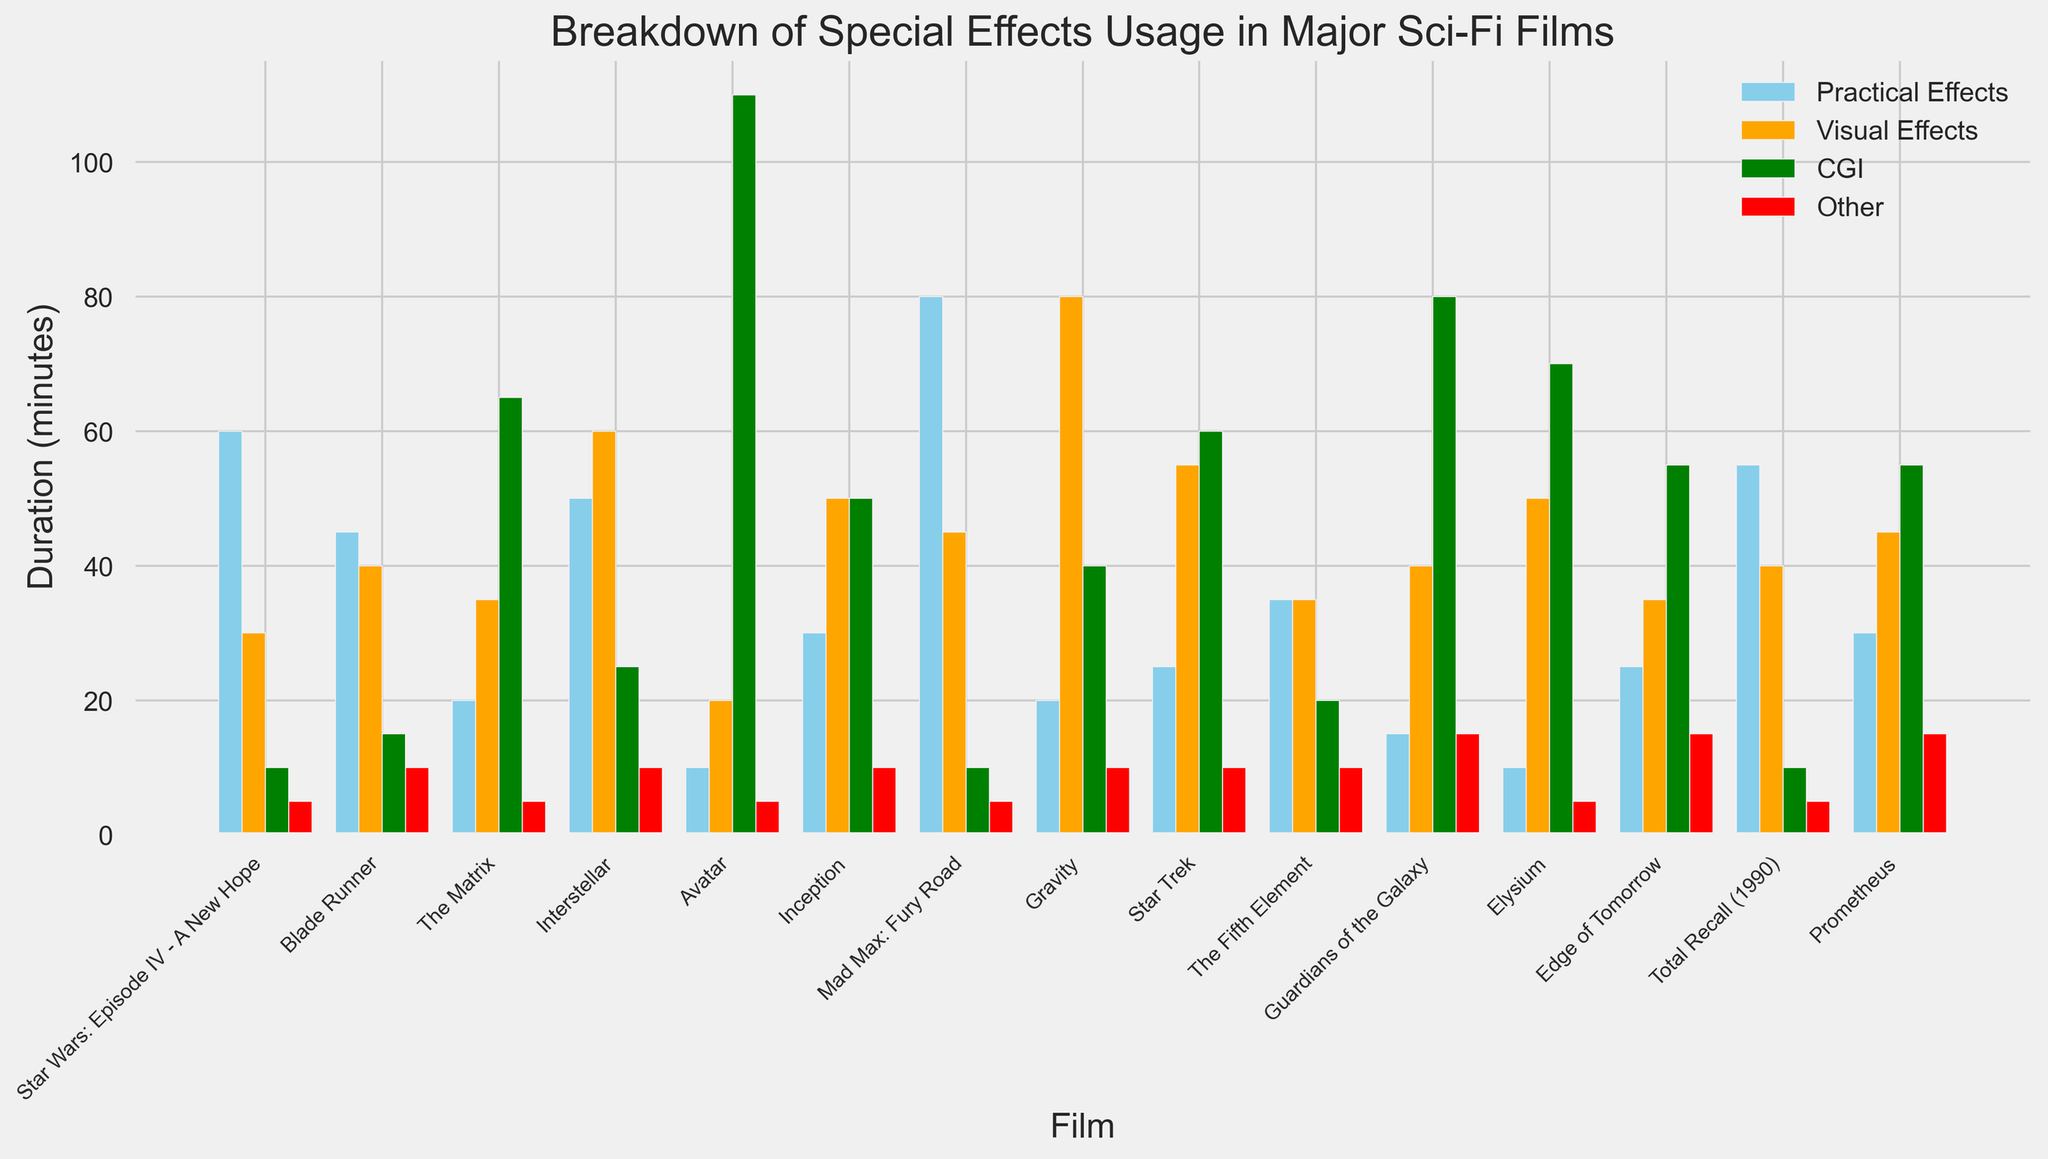Which film has the highest minutes of CGI usage? Locate the bars representing CGI usage (colored in green) and identify the tallest bar. This bar corresponds to the film with the highest minutes of CGI usage.
Answer: Avatar Which film has the least amount of practical effects? Look for the smallest bar in the practical effects (skyblue) category. This smallest bar corresponds to the film with the least practical effects.
Answer: Elysium What is the combined duration of practical and visual effects for "Star Wars: Episode IV - A New Hope"? Find the bars for "Star Wars: Episode IV - A New Hope" and add the durations of practical effects (60 minutes) and visual effects (30 minutes).
Answer: 90 minutes Compare the total special effects usage (sum of all categories) between "The Matrix" and "Inception". Which film uses more? Sum the practical effects, visual effects, CGI, and other effects for both films. For "The Matrix": 20 + 35 + 65 + 5 = 125 minutes. For "Inception": 30 + 50 + 50 + 10 = 140 minutes. Compare the totals to identify which film uses more.
Answer: Inception For "Mad Max: Fury Road", what is the ratio of practical effects to CGI? Take the practical effects duration (80 minutes) and divide it by the CGI duration (10 minutes). Calculate the ratio.
Answer: 8:1 Which film has the highest total duration of special effects? Sum the practical effects, visual effects, CGI, and other effects for each film and identify the highest sum.
Answer: Avatar What is the average CGI usage across all films? Calculate the total CGI usage by summing the CGI minutes of all films, then divide by the number of films: (10 + 15 + 65 + 25 + 110 + 50 + 10 + 40 + 60 + 20 + 80 + 70 + 55 + 10 + 55) / 15.
Answer: 39.3 minutes How many more minutes of visual effects does "Star Trek" have compared to "Blade Runner"? Subtract the visual effects minutes of "Blade Runner" (40 minutes) from the visual effects minutes of "Star Trek" (55 minutes).
Answer: 15 minutes Identify the films where CGI usage exceeds practical effects usage. Compare the CGI and practical effects bars for each film and list the films where the CGI bar is taller than the practical effects bar.
Answer: The Matrix, Avatar, Inception, Gravity, Star Trek, Guardians of the Galaxy, Elysium, Edge of Tomorrow, Prometheus Which film has the highest usage of "Other" effects, and what is the duration? Find the tallest bar in the "Other" effects category (red) and identify the film associated with it.
Answer: Guardians of the Galaxy, 15 minutes 